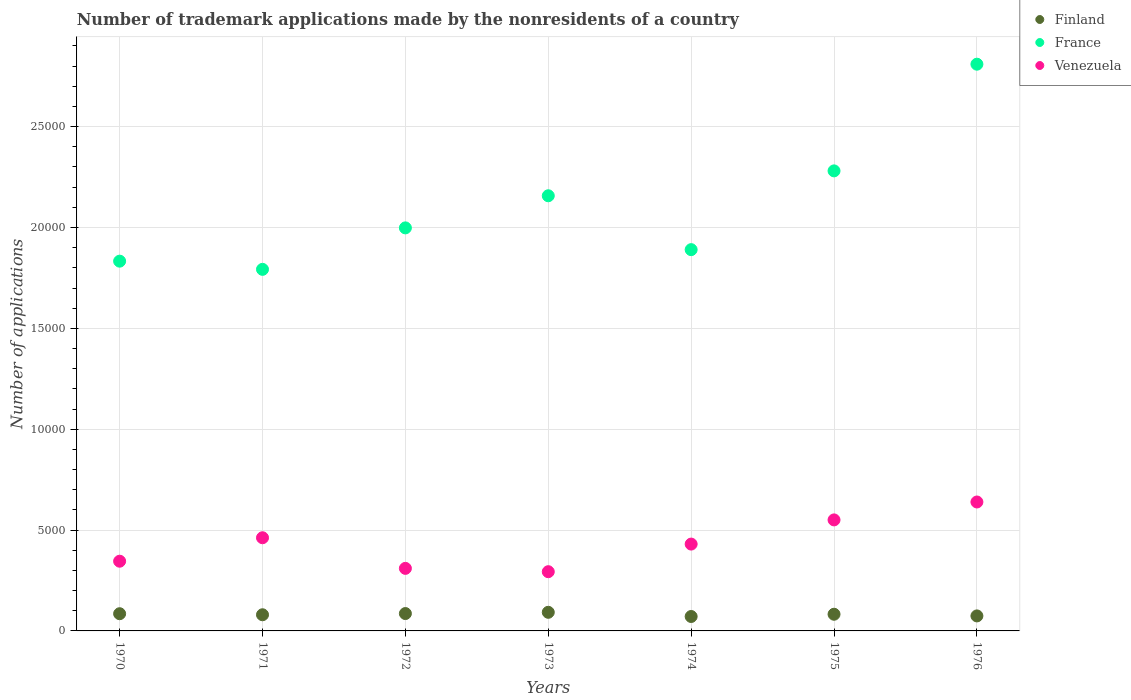Is the number of dotlines equal to the number of legend labels?
Offer a very short reply. Yes. What is the number of trademark applications made by the nonresidents in Finland in 1972?
Ensure brevity in your answer.  861. Across all years, what is the maximum number of trademark applications made by the nonresidents in Venezuela?
Make the answer very short. 6392. Across all years, what is the minimum number of trademark applications made by the nonresidents in France?
Offer a very short reply. 1.79e+04. In which year was the number of trademark applications made by the nonresidents in Venezuela maximum?
Offer a very short reply. 1976. In which year was the number of trademark applications made by the nonresidents in Finland minimum?
Offer a very short reply. 1974. What is the total number of trademark applications made by the nonresidents in France in the graph?
Provide a succinct answer. 1.48e+05. What is the difference between the number of trademark applications made by the nonresidents in Venezuela in 1972 and that in 1974?
Make the answer very short. -1204. What is the difference between the number of trademark applications made by the nonresidents in France in 1971 and the number of trademark applications made by the nonresidents in Finland in 1970?
Provide a succinct answer. 1.71e+04. What is the average number of trademark applications made by the nonresidents in Finland per year?
Offer a very short reply. 817.71. In the year 1974, what is the difference between the number of trademark applications made by the nonresidents in France and number of trademark applications made by the nonresidents in Finland?
Your answer should be very brief. 1.82e+04. In how many years, is the number of trademark applications made by the nonresidents in Venezuela greater than 4000?
Your answer should be very brief. 4. What is the ratio of the number of trademark applications made by the nonresidents in France in 1971 to that in 1972?
Provide a short and direct response. 0.9. Is the difference between the number of trademark applications made by the nonresidents in France in 1971 and 1972 greater than the difference between the number of trademark applications made by the nonresidents in Finland in 1971 and 1972?
Offer a very short reply. No. What is the difference between the highest and the second highest number of trademark applications made by the nonresidents in Venezuela?
Offer a terse response. 888. What is the difference between the highest and the lowest number of trademark applications made by the nonresidents in Finland?
Provide a short and direct response. 208. In how many years, is the number of trademark applications made by the nonresidents in France greater than the average number of trademark applications made by the nonresidents in France taken over all years?
Your answer should be compact. 3. Is it the case that in every year, the sum of the number of trademark applications made by the nonresidents in Venezuela and number of trademark applications made by the nonresidents in France  is greater than the number of trademark applications made by the nonresidents in Finland?
Provide a succinct answer. Yes. Is the number of trademark applications made by the nonresidents in Venezuela strictly less than the number of trademark applications made by the nonresidents in France over the years?
Ensure brevity in your answer.  Yes. How many years are there in the graph?
Give a very brief answer. 7. Are the values on the major ticks of Y-axis written in scientific E-notation?
Your answer should be compact. No. Does the graph contain any zero values?
Keep it short and to the point. No. Does the graph contain grids?
Keep it short and to the point. Yes. What is the title of the graph?
Make the answer very short. Number of trademark applications made by the nonresidents of a country. What is the label or title of the X-axis?
Offer a very short reply. Years. What is the label or title of the Y-axis?
Offer a very short reply. Number of applications. What is the Number of applications in Finland in 1970?
Your response must be concise. 853. What is the Number of applications in France in 1970?
Provide a short and direct response. 1.83e+04. What is the Number of applications in Venezuela in 1970?
Your response must be concise. 3456. What is the Number of applications in Finland in 1971?
Make the answer very short. 801. What is the Number of applications of France in 1971?
Keep it short and to the point. 1.79e+04. What is the Number of applications in Venezuela in 1971?
Offer a very short reply. 4619. What is the Number of applications of Finland in 1972?
Ensure brevity in your answer.  861. What is the Number of applications of France in 1972?
Your answer should be compact. 2.00e+04. What is the Number of applications in Venezuela in 1972?
Make the answer very short. 3101. What is the Number of applications of Finland in 1973?
Your answer should be compact. 923. What is the Number of applications in France in 1973?
Offer a terse response. 2.16e+04. What is the Number of applications of Venezuela in 1973?
Offer a terse response. 2936. What is the Number of applications of Finland in 1974?
Ensure brevity in your answer.  715. What is the Number of applications in France in 1974?
Ensure brevity in your answer.  1.89e+04. What is the Number of applications of Venezuela in 1974?
Make the answer very short. 4305. What is the Number of applications of Finland in 1975?
Give a very brief answer. 827. What is the Number of applications in France in 1975?
Your response must be concise. 2.28e+04. What is the Number of applications in Venezuela in 1975?
Your answer should be very brief. 5504. What is the Number of applications in Finland in 1976?
Provide a succinct answer. 744. What is the Number of applications in France in 1976?
Your answer should be compact. 2.81e+04. What is the Number of applications of Venezuela in 1976?
Keep it short and to the point. 6392. Across all years, what is the maximum Number of applications of Finland?
Your answer should be compact. 923. Across all years, what is the maximum Number of applications in France?
Your answer should be very brief. 2.81e+04. Across all years, what is the maximum Number of applications in Venezuela?
Your answer should be compact. 6392. Across all years, what is the minimum Number of applications in Finland?
Your answer should be compact. 715. Across all years, what is the minimum Number of applications of France?
Offer a terse response. 1.79e+04. Across all years, what is the minimum Number of applications of Venezuela?
Give a very brief answer. 2936. What is the total Number of applications in Finland in the graph?
Give a very brief answer. 5724. What is the total Number of applications of France in the graph?
Your answer should be very brief. 1.48e+05. What is the total Number of applications of Venezuela in the graph?
Ensure brevity in your answer.  3.03e+04. What is the difference between the Number of applications in France in 1970 and that in 1971?
Make the answer very short. 406. What is the difference between the Number of applications of Venezuela in 1970 and that in 1971?
Provide a short and direct response. -1163. What is the difference between the Number of applications of France in 1970 and that in 1972?
Ensure brevity in your answer.  -1650. What is the difference between the Number of applications in Venezuela in 1970 and that in 1972?
Keep it short and to the point. 355. What is the difference between the Number of applications of Finland in 1970 and that in 1973?
Your response must be concise. -70. What is the difference between the Number of applications of France in 1970 and that in 1973?
Make the answer very short. -3242. What is the difference between the Number of applications in Venezuela in 1970 and that in 1973?
Provide a succinct answer. 520. What is the difference between the Number of applications of Finland in 1970 and that in 1974?
Offer a terse response. 138. What is the difference between the Number of applications in France in 1970 and that in 1974?
Make the answer very short. -571. What is the difference between the Number of applications of Venezuela in 1970 and that in 1974?
Offer a terse response. -849. What is the difference between the Number of applications in Finland in 1970 and that in 1975?
Your response must be concise. 26. What is the difference between the Number of applications of France in 1970 and that in 1975?
Make the answer very short. -4476. What is the difference between the Number of applications of Venezuela in 1970 and that in 1975?
Your answer should be compact. -2048. What is the difference between the Number of applications in Finland in 1970 and that in 1976?
Provide a short and direct response. 109. What is the difference between the Number of applications of France in 1970 and that in 1976?
Your answer should be compact. -9765. What is the difference between the Number of applications of Venezuela in 1970 and that in 1976?
Your answer should be very brief. -2936. What is the difference between the Number of applications in Finland in 1971 and that in 1972?
Provide a short and direct response. -60. What is the difference between the Number of applications of France in 1971 and that in 1972?
Your answer should be very brief. -2056. What is the difference between the Number of applications in Venezuela in 1971 and that in 1972?
Your response must be concise. 1518. What is the difference between the Number of applications of Finland in 1971 and that in 1973?
Provide a short and direct response. -122. What is the difference between the Number of applications in France in 1971 and that in 1973?
Your response must be concise. -3648. What is the difference between the Number of applications in Venezuela in 1971 and that in 1973?
Your answer should be compact. 1683. What is the difference between the Number of applications of Finland in 1971 and that in 1974?
Keep it short and to the point. 86. What is the difference between the Number of applications in France in 1971 and that in 1974?
Offer a very short reply. -977. What is the difference between the Number of applications of Venezuela in 1971 and that in 1974?
Provide a short and direct response. 314. What is the difference between the Number of applications in Finland in 1971 and that in 1975?
Provide a succinct answer. -26. What is the difference between the Number of applications of France in 1971 and that in 1975?
Provide a short and direct response. -4882. What is the difference between the Number of applications of Venezuela in 1971 and that in 1975?
Offer a terse response. -885. What is the difference between the Number of applications of France in 1971 and that in 1976?
Give a very brief answer. -1.02e+04. What is the difference between the Number of applications of Venezuela in 1971 and that in 1976?
Your response must be concise. -1773. What is the difference between the Number of applications of Finland in 1972 and that in 1973?
Your answer should be compact. -62. What is the difference between the Number of applications in France in 1972 and that in 1973?
Keep it short and to the point. -1592. What is the difference between the Number of applications in Venezuela in 1972 and that in 1973?
Your answer should be very brief. 165. What is the difference between the Number of applications in Finland in 1972 and that in 1974?
Your response must be concise. 146. What is the difference between the Number of applications in France in 1972 and that in 1974?
Make the answer very short. 1079. What is the difference between the Number of applications of Venezuela in 1972 and that in 1974?
Provide a short and direct response. -1204. What is the difference between the Number of applications in Finland in 1972 and that in 1975?
Your answer should be compact. 34. What is the difference between the Number of applications of France in 1972 and that in 1975?
Keep it short and to the point. -2826. What is the difference between the Number of applications of Venezuela in 1972 and that in 1975?
Offer a very short reply. -2403. What is the difference between the Number of applications of Finland in 1972 and that in 1976?
Offer a terse response. 117. What is the difference between the Number of applications of France in 1972 and that in 1976?
Offer a very short reply. -8115. What is the difference between the Number of applications in Venezuela in 1972 and that in 1976?
Offer a terse response. -3291. What is the difference between the Number of applications in Finland in 1973 and that in 1974?
Your answer should be very brief. 208. What is the difference between the Number of applications in France in 1973 and that in 1974?
Offer a very short reply. 2671. What is the difference between the Number of applications of Venezuela in 1973 and that in 1974?
Provide a short and direct response. -1369. What is the difference between the Number of applications in Finland in 1973 and that in 1975?
Your response must be concise. 96. What is the difference between the Number of applications in France in 1973 and that in 1975?
Make the answer very short. -1234. What is the difference between the Number of applications in Venezuela in 1973 and that in 1975?
Make the answer very short. -2568. What is the difference between the Number of applications of Finland in 1973 and that in 1976?
Your answer should be compact. 179. What is the difference between the Number of applications of France in 1973 and that in 1976?
Your response must be concise. -6523. What is the difference between the Number of applications of Venezuela in 1973 and that in 1976?
Offer a very short reply. -3456. What is the difference between the Number of applications of Finland in 1974 and that in 1975?
Provide a succinct answer. -112. What is the difference between the Number of applications of France in 1974 and that in 1975?
Provide a short and direct response. -3905. What is the difference between the Number of applications of Venezuela in 1974 and that in 1975?
Ensure brevity in your answer.  -1199. What is the difference between the Number of applications in France in 1974 and that in 1976?
Keep it short and to the point. -9194. What is the difference between the Number of applications in Venezuela in 1974 and that in 1976?
Provide a succinct answer. -2087. What is the difference between the Number of applications of France in 1975 and that in 1976?
Your response must be concise. -5289. What is the difference between the Number of applications of Venezuela in 1975 and that in 1976?
Make the answer very short. -888. What is the difference between the Number of applications of Finland in 1970 and the Number of applications of France in 1971?
Offer a terse response. -1.71e+04. What is the difference between the Number of applications of Finland in 1970 and the Number of applications of Venezuela in 1971?
Keep it short and to the point. -3766. What is the difference between the Number of applications of France in 1970 and the Number of applications of Venezuela in 1971?
Make the answer very short. 1.37e+04. What is the difference between the Number of applications of Finland in 1970 and the Number of applications of France in 1972?
Offer a terse response. -1.91e+04. What is the difference between the Number of applications in Finland in 1970 and the Number of applications in Venezuela in 1972?
Offer a very short reply. -2248. What is the difference between the Number of applications of France in 1970 and the Number of applications of Venezuela in 1972?
Your answer should be compact. 1.52e+04. What is the difference between the Number of applications of Finland in 1970 and the Number of applications of France in 1973?
Keep it short and to the point. -2.07e+04. What is the difference between the Number of applications in Finland in 1970 and the Number of applications in Venezuela in 1973?
Give a very brief answer. -2083. What is the difference between the Number of applications of France in 1970 and the Number of applications of Venezuela in 1973?
Offer a terse response. 1.54e+04. What is the difference between the Number of applications in Finland in 1970 and the Number of applications in France in 1974?
Make the answer very short. -1.80e+04. What is the difference between the Number of applications in Finland in 1970 and the Number of applications in Venezuela in 1974?
Keep it short and to the point. -3452. What is the difference between the Number of applications of France in 1970 and the Number of applications of Venezuela in 1974?
Provide a succinct answer. 1.40e+04. What is the difference between the Number of applications in Finland in 1970 and the Number of applications in France in 1975?
Offer a terse response. -2.20e+04. What is the difference between the Number of applications of Finland in 1970 and the Number of applications of Venezuela in 1975?
Your answer should be very brief. -4651. What is the difference between the Number of applications in France in 1970 and the Number of applications in Venezuela in 1975?
Ensure brevity in your answer.  1.28e+04. What is the difference between the Number of applications of Finland in 1970 and the Number of applications of France in 1976?
Your answer should be very brief. -2.72e+04. What is the difference between the Number of applications of Finland in 1970 and the Number of applications of Venezuela in 1976?
Your answer should be compact. -5539. What is the difference between the Number of applications in France in 1970 and the Number of applications in Venezuela in 1976?
Provide a short and direct response. 1.19e+04. What is the difference between the Number of applications of Finland in 1971 and the Number of applications of France in 1972?
Keep it short and to the point. -1.92e+04. What is the difference between the Number of applications of Finland in 1971 and the Number of applications of Venezuela in 1972?
Offer a very short reply. -2300. What is the difference between the Number of applications in France in 1971 and the Number of applications in Venezuela in 1972?
Make the answer very short. 1.48e+04. What is the difference between the Number of applications in Finland in 1971 and the Number of applications in France in 1973?
Your answer should be compact. -2.08e+04. What is the difference between the Number of applications in Finland in 1971 and the Number of applications in Venezuela in 1973?
Offer a terse response. -2135. What is the difference between the Number of applications in France in 1971 and the Number of applications in Venezuela in 1973?
Keep it short and to the point. 1.50e+04. What is the difference between the Number of applications in Finland in 1971 and the Number of applications in France in 1974?
Give a very brief answer. -1.81e+04. What is the difference between the Number of applications of Finland in 1971 and the Number of applications of Venezuela in 1974?
Offer a very short reply. -3504. What is the difference between the Number of applications in France in 1971 and the Number of applications in Venezuela in 1974?
Provide a short and direct response. 1.36e+04. What is the difference between the Number of applications in Finland in 1971 and the Number of applications in France in 1975?
Make the answer very short. -2.20e+04. What is the difference between the Number of applications of Finland in 1971 and the Number of applications of Venezuela in 1975?
Keep it short and to the point. -4703. What is the difference between the Number of applications in France in 1971 and the Number of applications in Venezuela in 1975?
Keep it short and to the point. 1.24e+04. What is the difference between the Number of applications in Finland in 1971 and the Number of applications in France in 1976?
Your answer should be compact. -2.73e+04. What is the difference between the Number of applications of Finland in 1971 and the Number of applications of Venezuela in 1976?
Your response must be concise. -5591. What is the difference between the Number of applications of France in 1971 and the Number of applications of Venezuela in 1976?
Provide a short and direct response. 1.15e+04. What is the difference between the Number of applications in Finland in 1972 and the Number of applications in France in 1973?
Provide a succinct answer. -2.07e+04. What is the difference between the Number of applications in Finland in 1972 and the Number of applications in Venezuela in 1973?
Provide a succinct answer. -2075. What is the difference between the Number of applications of France in 1972 and the Number of applications of Venezuela in 1973?
Provide a short and direct response. 1.70e+04. What is the difference between the Number of applications of Finland in 1972 and the Number of applications of France in 1974?
Ensure brevity in your answer.  -1.80e+04. What is the difference between the Number of applications in Finland in 1972 and the Number of applications in Venezuela in 1974?
Offer a very short reply. -3444. What is the difference between the Number of applications in France in 1972 and the Number of applications in Venezuela in 1974?
Your answer should be very brief. 1.57e+04. What is the difference between the Number of applications of Finland in 1972 and the Number of applications of France in 1975?
Give a very brief answer. -2.19e+04. What is the difference between the Number of applications of Finland in 1972 and the Number of applications of Venezuela in 1975?
Your response must be concise. -4643. What is the difference between the Number of applications in France in 1972 and the Number of applications in Venezuela in 1975?
Make the answer very short. 1.45e+04. What is the difference between the Number of applications of Finland in 1972 and the Number of applications of France in 1976?
Keep it short and to the point. -2.72e+04. What is the difference between the Number of applications in Finland in 1972 and the Number of applications in Venezuela in 1976?
Your answer should be very brief. -5531. What is the difference between the Number of applications of France in 1972 and the Number of applications of Venezuela in 1976?
Keep it short and to the point. 1.36e+04. What is the difference between the Number of applications of Finland in 1973 and the Number of applications of France in 1974?
Ensure brevity in your answer.  -1.80e+04. What is the difference between the Number of applications of Finland in 1973 and the Number of applications of Venezuela in 1974?
Provide a succinct answer. -3382. What is the difference between the Number of applications of France in 1973 and the Number of applications of Venezuela in 1974?
Offer a very short reply. 1.73e+04. What is the difference between the Number of applications of Finland in 1973 and the Number of applications of France in 1975?
Your answer should be very brief. -2.19e+04. What is the difference between the Number of applications of Finland in 1973 and the Number of applications of Venezuela in 1975?
Keep it short and to the point. -4581. What is the difference between the Number of applications of France in 1973 and the Number of applications of Venezuela in 1975?
Keep it short and to the point. 1.61e+04. What is the difference between the Number of applications of Finland in 1973 and the Number of applications of France in 1976?
Provide a succinct answer. -2.72e+04. What is the difference between the Number of applications of Finland in 1973 and the Number of applications of Venezuela in 1976?
Provide a short and direct response. -5469. What is the difference between the Number of applications of France in 1973 and the Number of applications of Venezuela in 1976?
Offer a very short reply. 1.52e+04. What is the difference between the Number of applications of Finland in 1974 and the Number of applications of France in 1975?
Give a very brief answer. -2.21e+04. What is the difference between the Number of applications of Finland in 1974 and the Number of applications of Venezuela in 1975?
Make the answer very short. -4789. What is the difference between the Number of applications of France in 1974 and the Number of applications of Venezuela in 1975?
Your answer should be compact. 1.34e+04. What is the difference between the Number of applications of Finland in 1974 and the Number of applications of France in 1976?
Ensure brevity in your answer.  -2.74e+04. What is the difference between the Number of applications of Finland in 1974 and the Number of applications of Venezuela in 1976?
Keep it short and to the point. -5677. What is the difference between the Number of applications of France in 1974 and the Number of applications of Venezuela in 1976?
Keep it short and to the point. 1.25e+04. What is the difference between the Number of applications of Finland in 1975 and the Number of applications of France in 1976?
Offer a terse response. -2.73e+04. What is the difference between the Number of applications of Finland in 1975 and the Number of applications of Venezuela in 1976?
Give a very brief answer. -5565. What is the difference between the Number of applications of France in 1975 and the Number of applications of Venezuela in 1976?
Your response must be concise. 1.64e+04. What is the average Number of applications in Finland per year?
Provide a short and direct response. 817.71. What is the average Number of applications in France per year?
Your answer should be very brief. 2.11e+04. What is the average Number of applications in Venezuela per year?
Provide a succinct answer. 4330.43. In the year 1970, what is the difference between the Number of applications of Finland and Number of applications of France?
Provide a short and direct response. -1.75e+04. In the year 1970, what is the difference between the Number of applications in Finland and Number of applications in Venezuela?
Provide a succinct answer. -2603. In the year 1970, what is the difference between the Number of applications in France and Number of applications in Venezuela?
Ensure brevity in your answer.  1.49e+04. In the year 1971, what is the difference between the Number of applications of Finland and Number of applications of France?
Keep it short and to the point. -1.71e+04. In the year 1971, what is the difference between the Number of applications in Finland and Number of applications in Venezuela?
Your answer should be compact. -3818. In the year 1971, what is the difference between the Number of applications in France and Number of applications in Venezuela?
Provide a short and direct response. 1.33e+04. In the year 1972, what is the difference between the Number of applications in Finland and Number of applications in France?
Provide a short and direct response. -1.91e+04. In the year 1972, what is the difference between the Number of applications in Finland and Number of applications in Venezuela?
Make the answer very short. -2240. In the year 1972, what is the difference between the Number of applications in France and Number of applications in Venezuela?
Provide a succinct answer. 1.69e+04. In the year 1973, what is the difference between the Number of applications of Finland and Number of applications of France?
Your response must be concise. -2.06e+04. In the year 1973, what is the difference between the Number of applications in Finland and Number of applications in Venezuela?
Ensure brevity in your answer.  -2013. In the year 1973, what is the difference between the Number of applications of France and Number of applications of Venezuela?
Give a very brief answer. 1.86e+04. In the year 1974, what is the difference between the Number of applications of Finland and Number of applications of France?
Offer a very short reply. -1.82e+04. In the year 1974, what is the difference between the Number of applications of Finland and Number of applications of Venezuela?
Make the answer very short. -3590. In the year 1974, what is the difference between the Number of applications in France and Number of applications in Venezuela?
Your response must be concise. 1.46e+04. In the year 1975, what is the difference between the Number of applications of Finland and Number of applications of France?
Your answer should be very brief. -2.20e+04. In the year 1975, what is the difference between the Number of applications of Finland and Number of applications of Venezuela?
Give a very brief answer. -4677. In the year 1975, what is the difference between the Number of applications of France and Number of applications of Venezuela?
Keep it short and to the point. 1.73e+04. In the year 1976, what is the difference between the Number of applications of Finland and Number of applications of France?
Your answer should be compact. -2.74e+04. In the year 1976, what is the difference between the Number of applications of Finland and Number of applications of Venezuela?
Keep it short and to the point. -5648. In the year 1976, what is the difference between the Number of applications in France and Number of applications in Venezuela?
Offer a terse response. 2.17e+04. What is the ratio of the Number of applications of Finland in 1970 to that in 1971?
Ensure brevity in your answer.  1.06. What is the ratio of the Number of applications in France in 1970 to that in 1971?
Your answer should be very brief. 1.02. What is the ratio of the Number of applications in Venezuela in 1970 to that in 1971?
Keep it short and to the point. 0.75. What is the ratio of the Number of applications in Finland in 1970 to that in 1972?
Keep it short and to the point. 0.99. What is the ratio of the Number of applications in France in 1970 to that in 1972?
Make the answer very short. 0.92. What is the ratio of the Number of applications of Venezuela in 1970 to that in 1972?
Give a very brief answer. 1.11. What is the ratio of the Number of applications of Finland in 1970 to that in 1973?
Your response must be concise. 0.92. What is the ratio of the Number of applications of France in 1970 to that in 1973?
Your answer should be very brief. 0.85. What is the ratio of the Number of applications in Venezuela in 1970 to that in 1973?
Ensure brevity in your answer.  1.18. What is the ratio of the Number of applications in Finland in 1970 to that in 1974?
Your response must be concise. 1.19. What is the ratio of the Number of applications in France in 1970 to that in 1974?
Your answer should be very brief. 0.97. What is the ratio of the Number of applications in Venezuela in 1970 to that in 1974?
Give a very brief answer. 0.8. What is the ratio of the Number of applications in Finland in 1970 to that in 1975?
Give a very brief answer. 1.03. What is the ratio of the Number of applications in France in 1970 to that in 1975?
Provide a succinct answer. 0.8. What is the ratio of the Number of applications of Venezuela in 1970 to that in 1975?
Your response must be concise. 0.63. What is the ratio of the Number of applications of Finland in 1970 to that in 1976?
Ensure brevity in your answer.  1.15. What is the ratio of the Number of applications in France in 1970 to that in 1976?
Provide a succinct answer. 0.65. What is the ratio of the Number of applications of Venezuela in 1970 to that in 1976?
Ensure brevity in your answer.  0.54. What is the ratio of the Number of applications of Finland in 1971 to that in 1972?
Your response must be concise. 0.93. What is the ratio of the Number of applications in France in 1971 to that in 1972?
Ensure brevity in your answer.  0.9. What is the ratio of the Number of applications of Venezuela in 1971 to that in 1972?
Make the answer very short. 1.49. What is the ratio of the Number of applications in Finland in 1971 to that in 1973?
Ensure brevity in your answer.  0.87. What is the ratio of the Number of applications in France in 1971 to that in 1973?
Provide a succinct answer. 0.83. What is the ratio of the Number of applications in Venezuela in 1971 to that in 1973?
Provide a short and direct response. 1.57. What is the ratio of the Number of applications in Finland in 1971 to that in 1974?
Give a very brief answer. 1.12. What is the ratio of the Number of applications of France in 1971 to that in 1974?
Provide a succinct answer. 0.95. What is the ratio of the Number of applications in Venezuela in 1971 to that in 1974?
Give a very brief answer. 1.07. What is the ratio of the Number of applications of Finland in 1971 to that in 1975?
Provide a succinct answer. 0.97. What is the ratio of the Number of applications in France in 1971 to that in 1975?
Offer a very short reply. 0.79. What is the ratio of the Number of applications in Venezuela in 1971 to that in 1975?
Offer a terse response. 0.84. What is the ratio of the Number of applications in Finland in 1971 to that in 1976?
Make the answer very short. 1.08. What is the ratio of the Number of applications in France in 1971 to that in 1976?
Provide a short and direct response. 0.64. What is the ratio of the Number of applications of Venezuela in 1971 to that in 1976?
Keep it short and to the point. 0.72. What is the ratio of the Number of applications of Finland in 1972 to that in 1973?
Your answer should be very brief. 0.93. What is the ratio of the Number of applications of France in 1972 to that in 1973?
Ensure brevity in your answer.  0.93. What is the ratio of the Number of applications in Venezuela in 1972 to that in 1973?
Your answer should be very brief. 1.06. What is the ratio of the Number of applications of Finland in 1972 to that in 1974?
Offer a terse response. 1.2. What is the ratio of the Number of applications of France in 1972 to that in 1974?
Keep it short and to the point. 1.06. What is the ratio of the Number of applications of Venezuela in 1972 to that in 1974?
Provide a short and direct response. 0.72. What is the ratio of the Number of applications in Finland in 1972 to that in 1975?
Offer a terse response. 1.04. What is the ratio of the Number of applications of France in 1972 to that in 1975?
Offer a very short reply. 0.88. What is the ratio of the Number of applications in Venezuela in 1972 to that in 1975?
Your answer should be very brief. 0.56. What is the ratio of the Number of applications of Finland in 1972 to that in 1976?
Offer a terse response. 1.16. What is the ratio of the Number of applications of France in 1972 to that in 1976?
Your answer should be very brief. 0.71. What is the ratio of the Number of applications of Venezuela in 1972 to that in 1976?
Provide a succinct answer. 0.49. What is the ratio of the Number of applications of Finland in 1973 to that in 1974?
Keep it short and to the point. 1.29. What is the ratio of the Number of applications of France in 1973 to that in 1974?
Ensure brevity in your answer.  1.14. What is the ratio of the Number of applications in Venezuela in 1973 to that in 1974?
Offer a very short reply. 0.68. What is the ratio of the Number of applications of Finland in 1973 to that in 1975?
Your answer should be compact. 1.12. What is the ratio of the Number of applications in France in 1973 to that in 1975?
Offer a very short reply. 0.95. What is the ratio of the Number of applications in Venezuela in 1973 to that in 1975?
Provide a succinct answer. 0.53. What is the ratio of the Number of applications in Finland in 1973 to that in 1976?
Your response must be concise. 1.24. What is the ratio of the Number of applications of France in 1973 to that in 1976?
Offer a terse response. 0.77. What is the ratio of the Number of applications in Venezuela in 1973 to that in 1976?
Make the answer very short. 0.46. What is the ratio of the Number of applications of Finland in 1974 to that in 1975?
Offer a very short reply. 0.86. What is the ratio of the Number of applications in France in 1974 to that in 1975?
Offer a terse response. 0.83. What is the ratio of the Number of applications of Venezuela in 1974 to that in 1975?
Your answer should be compact. 0.78. What is the ratio of the Number of applications of Finland in 1974 to that in 1976?
Offer a very short reply. 0.96. What is the ratio of the Number of applications of France in 1974 to that in 1976?
Your response must be concise. 0.67. What is the ratio of the Number of applications of Venezuela in 1974 to that in 1976?
Make the answer very short. 0.67. What is the ratio of the Number of applications of Finland in 1975 to that in 1976?
Give a very brief answer. 1.11. What is the ratio of the Number of applications in France in 1975 to that in 1976?
Offer a terse response. 0.81. What is the ratio of the Number of applications in Venezuela in 1975 to that in 1976?
Your response must be concise. 0.86. What is the difference between the highest and the second highest Number of applications in Finland?
Ensure brevity in your answer.  62. What is the difference between the highest and the second highest Number of applications of France?
Give a very brief answer. 5289. What is the difference between the highest and the second highest Number of applications of Venezuela?
Ensure brevity in your answer.  888. What is the difference between the highest and the lowest Number of applications in Finland?
Your response must be concise. 208. What is the difference between the highest and the lowest Number of applications of France?
Give a very brief answer. 1.02e+04. What is the difference between the highest and the lowest Number of applications of Venezuela?
Your answer should be compact. 3456. 